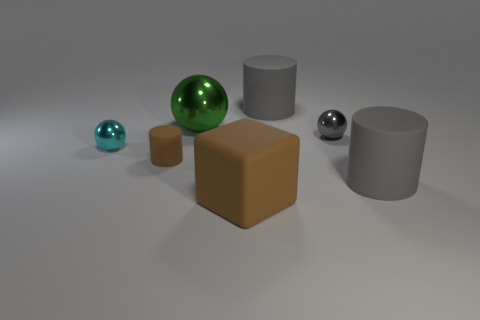What could be the purpose of the green spherical object? Given the context of the image, the green spherical object might be a decorative element or a simulated glass ball in a virtual setting, meant for visual appeal or graphic design exercises. How could you use this green object in a real-world setting? In a real-world setting, an object like this could serve as a paperweight, a decorative piece on a desk or shelf, or potentially as part of a display in an educational context about materials and their properties. 